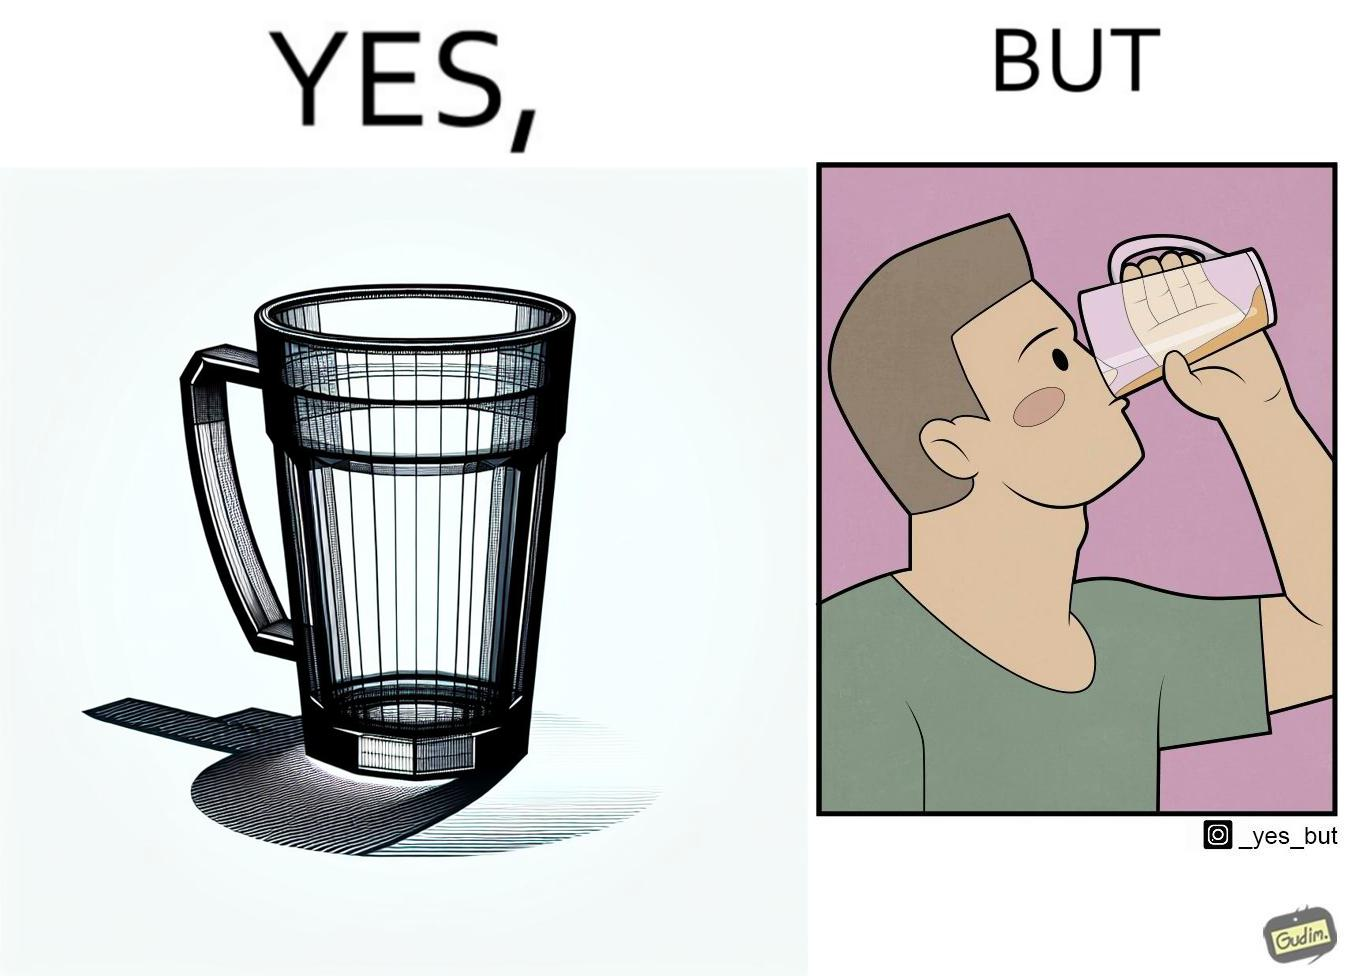Describe the content of this image. This image is funny because even though the tumbler has a glass handle on it to facilitate holding, the person drinking from it doesn't use the handle making it redundant. 